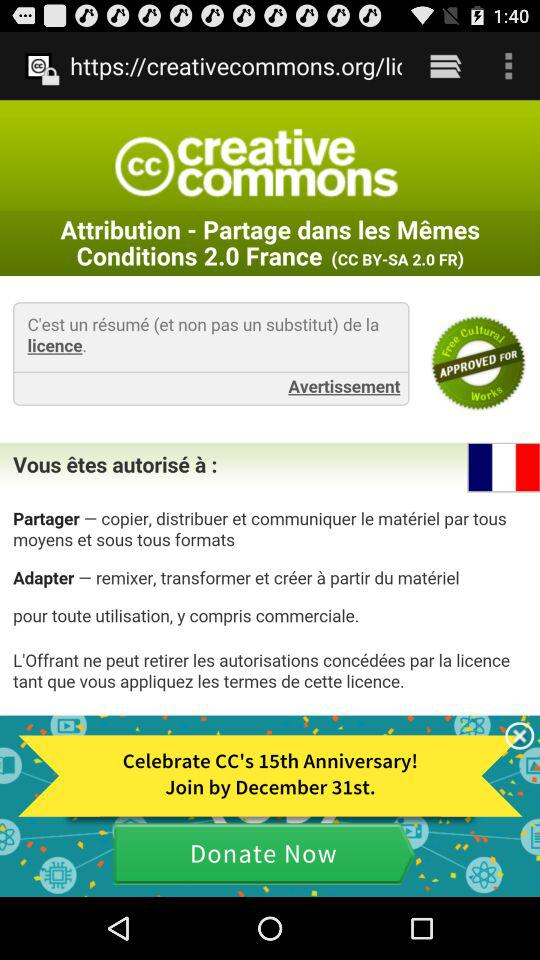What is the date of Anniversary?
When the provided information is insufficient, respond with <no answer>. <no answer> 